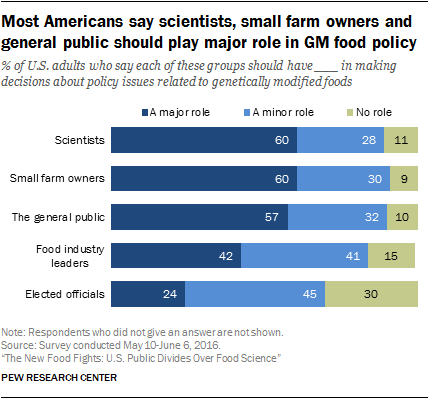Mention a couple of crucial points in this snapshot. The median of navy blue bars is greater than the largest value of light blue bars. The color of the smallest bar is green, and it is true. 